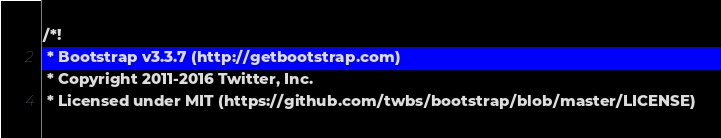Convert code to text. <code><loc_0><loc_0><loc_500><loc_500><_CSS_>/*!
 * Bootstrap v3.3.7 (http://getbootstrap.com)
 * Copyright 2011-2016 Twitter, Inc.
 * Licensed under MIT (https://github.com/twbs/bootstrap/blob/master/LICENSE)</code> 